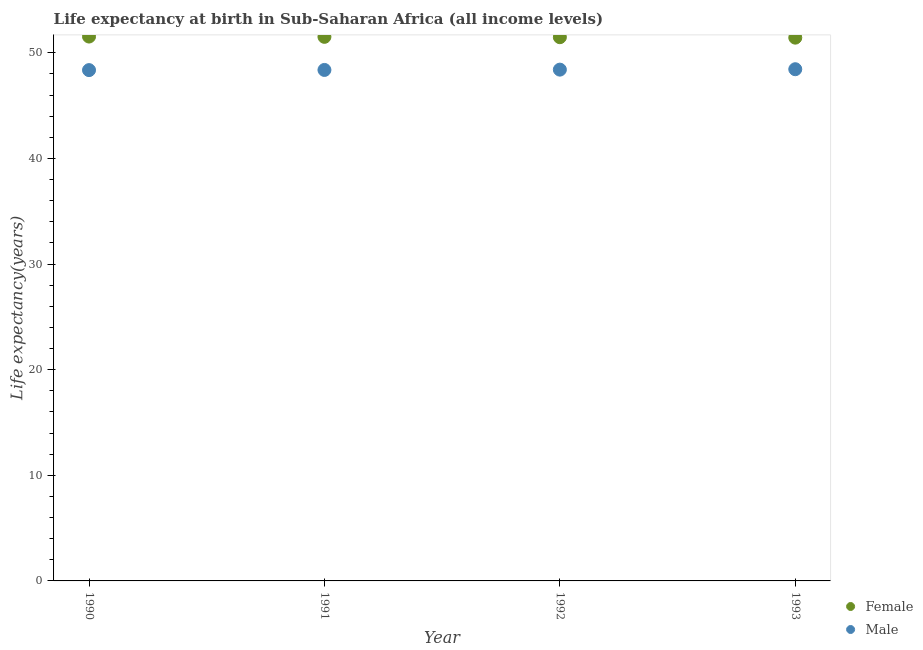What is the life expectancy(male) in 1991?
Offer a very short reply. 48.38. Across all years, what is the maximum life expectancy(male)?
Provide a short and direct response. 48.45. Across all years, what is the minimum life expectancy(male)?
Your answer should be very brief. 48.37. What is the total life expectancy(male) in the graph?
Offer a very short reply. 193.61. What is the difference between the life expectancy(male) in 1992 and that in 1993?
Keep it short and to the point. -0.04. What is the difference between the life expectancy(male) in 1990 and the life expectancy(female) in 1991?
Offer a terse response. -3.15. What is the average life expectancy(female) per year?
Offer a very short reply. 51.5. In the year 1992, what is the difference between the life expectancy(female) and life expectancy(male)?
Provide a succinct answer. 3.07. What is the ratio of the life expectancy(female) in 1990 to that in 1991?
Give a very brief answer. 1. Is the difference between the life expectancy(male) in 1990 and 1992 greater than the difference between the life expectancy(female) in 1990 and 1992?
Keep it short and to the point. No. What is the difference between the highest and the second highest life expectancy(female)?
Offer a very short reply. 0.03. What is the difference between the highest and the lowest life expectancy(male)?
Make the answer very short. 0.08. In how many years, is the life expectancy(male) greater than the average life expectancy(male) taken over all years?
Your answer should be very brief. 2. Is the life expectancy(male) strictly less than the life expectancy(female) over the years?
Your answer should be very brief. Yes. How many dotlines are there?
Make the answer very short. 2. How many years are there in the graph?
Your response must be concise. 4. Does the graph contain any zero values?
Your answer should be very brief. No. Where does the legend appear in the graph?
Give a very brief answer. Bottom right. What is the title of the graph?
Provide a short and direct response. Life expectancy at birth in Sub-Saharan Africa (all income levels). Does "Non-pregnant women" appear as one of the legend labels in the graph?
Your response must be concise. No. What is the label or title of the Y-axis?
Provide a succinct answer. Life expectancy(years). What is the Life expectancy(years) in Female in 1990?
Ensure brevity in your answer.  51.54. What is the Life expectancy(years) of Male in 1990?
Ensure brevity in your answer.  48.37. What is the Life expectancy(years) in Female in 1991?
Your answer should be compact. 51.52. What is the Life expectancy(years) in Male in 1991?
Offer a very short reply. 48.38. What is the Life expectancy(years) in Female in 1992?
Offer a terse response. 51.48. What is the Life expectancy(years) of Male in 1992?
Your response must be concise. 48.41. What is the Life expectancy(years) of Female in 1993?
Keep it short and to the point. 51.44. What is the Life expectancy(years) of Male in 1993?
Give a very brief answer. 48.45. Across all years, what is the maximum Life expectancy(years) of Female?
Your response must be concise. 51.54. Across all years, what is the maximum Life expectancy(years) in Male?
Give a very brief answer. 48.45. Across all years, what is the minimum Life expectancy(years) of Female?
Your answer should be very brief. 51.44. Across all years, what is the minimum Life expectancy(years) in Male?
Your answer should be very brief. 48.37. What is the total Life expectancy(years) of Female in the graph?
Make the answer very short. 205.98. What is the total Life expectancy(years) of Male in the graph?
Your response must be concise. 193.61. What is the difference between the Life expectancy(years) of Female in 1990 and that in 1991?
Give a very brief answer. 0.03. What is the difference between the Life expectancy(years) of Male in 1990 and that in 1991?
Keep it short and to the point. -0.02. What is the difference between the Life expectancy(years) of Female in 1990 and that in 1992?
Give a very brief answer. 0.06. What is the difference between the Life expectancy(years) in Male in 1990 and that in 1992?
Provide a succinct answer. -0.05. What is the difference between the Life expectancy(years) of Female in 1990 and that in 1993?
Give a very brief answer. 0.1. What is the difference between the Life expectancy(years) of Male in 1990 and that in 1993?
Give a very brief answer. -0.08. What is the difference between the Life expectancy(years) in Female in 1991 and that in 1992?
Make the answer very short. 0.03. What is the difference between the Life expectancy(years) of Male in 1991 and that in 1992?
Provide a short and direct response. -0.03. What is the difference between the Life expectancy(years) of Female in 1991 and that in 1993?
Your answer should be compact. 0.08. What is the difference between the Life expectancy(years) in Male in 1991 and that in 1993?
Offer a very short reply. -0.07. What is the difference between the Life expectancy(years) of Female in 1992 and that in 1993?
Make the answer very short. 0.04. What is the difference between the Life expectancy(years) in Male in 1992 and that in 1993?
Make the answer very short. -0.04. What is the difference between the Life expectancy(years) in Female in 1990 and the Life expectancy(years) in Male in 1991?
Provide a succinct answer. 3.16. What is the difference between the Life expectancy(years) of Female in 1990 and the Life expectancy(years) of Male in 1992?
Ensure brevity in your answer.  3.13. What is the difference between the Life expectancy(years) of Female in 1990 and the Life expectancy(years) of Male in 1993?
Give a very brief answer. 3.09. What is the difference between the Life expectancy(years) of Female in 1991 and the Life expectancy(years) of Male in 1992?
Provide a short and direct response. 3.1. What is the difference between the Life expectancy(years) in Female in 1991 and the Life expectancy(years) in Male in 1993?
Offer a terse response. 3.07. What is the difference between the Life expectancy(years) in Female in 1992 and the Life expectancy(years) in Male in 1993?
Your answer should be compact. 3.03. What is the average Life expectancy(years) in Female per year?
Provide a short and direct response. 51.5. What is the average Life expectancy(years) in Male per year?
Your answer should be very brief. 48.4. In the year 1990, what is the difference between the Life expectancy(years) in Female and Life expectancy(years) in Male?
Your response must be concise. 3.18. In the year 1991, what is the difference between the Life expectancy(years) of Female and Life expectancy(years) of Male?
Ensure brevity in your answer.  3.13. In the year 1992, what is the difference between the Life expectancy(years) of Female and Life expectancy(years) of Male?
Ensure brevity in your answer.  3.07. In the year 1993, what is the difference between the Life expectancy(years) in Female and Life expectancy(years) in Male?
Ensure brevity in your answer.  2.99. What is the ratio of the Life expectancy(years) in Male in 1990 to that in 1991?
Your answer should be compact. 1. What is the ratio of the Life expectancy(years) of Female in 1990 to that in 1992?
Provide a succinct answer. 1. What is the ratio of the Life expectancy(years) in Male in 1990 to that in 1993?
Provide a succinct answer. 1. What is the ratio of the Life expectancy(years) in Male in 1991 to that in 1992?
Keep it short and to the point. 1. What is the ratio of the Life expectancy(years) in Female in 1991 to that in 1993?
Give a very brief answer. 1. What is the ratio of the Life expectancy(years) of Male in 1991 to that in 1993?
Provide a short and direct response. 1. What is the ratio of the Life expectancy(years) of Male in 1992 to that in 1993?
Your answer should be very brief. 1. What is the difference between the highest and the second highest Life expectancy(years) in Female?
Your answer should be compact. 0.03. What is the difference between the highest and the second highest Life expectancy(years) in Male?
Ensure brevity in your answer.  0.04. What is the difference between the highest and the lowest Life expectancy(years) of Female?
Your answer should be very brief. 0.1. What is the difference between the highest and the lowest Life expectancy(years) of Male?
Your answer should be very brief. 0.08. 